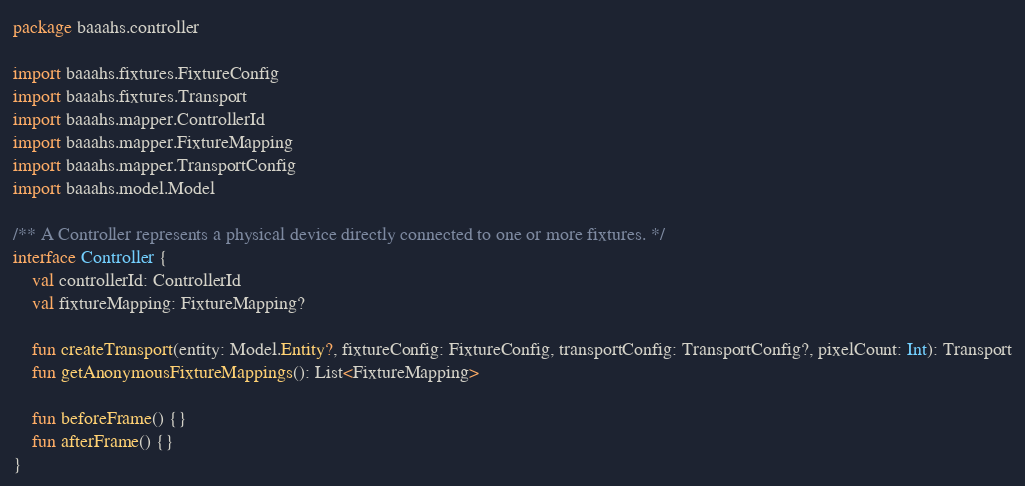Convert code to text. <code><loc_0><loc_0><loc_500><loc_500><_Kotlin_>package baaahs.controller

import baaahs.fixtures.FixtureConfig
import baaahs.fixtures.Transport
import baaahs.mapper.ControllerId
import baaahs.mapper.FixtureMapping
import baaahs.mapper.TransportConfig
import baaahs.model.Model

/** A Controller represents a physical device directly connected to one or more fixtures. */
interface Controller {
    val controllerId: ControllerId
    val fixtureMapping: FixtureMapping?

    fun createTransport(entity: Model.Entity?, fixtureConfig: FixtureConfig, transportConfig: TransportConfig?, pixelCount: Int): Transport
    fun getAnonymousFixtureMappings(): List<FixtureMapping>

    fun beforeFrame() {}
    fun afterFrame() {}
}</code> 